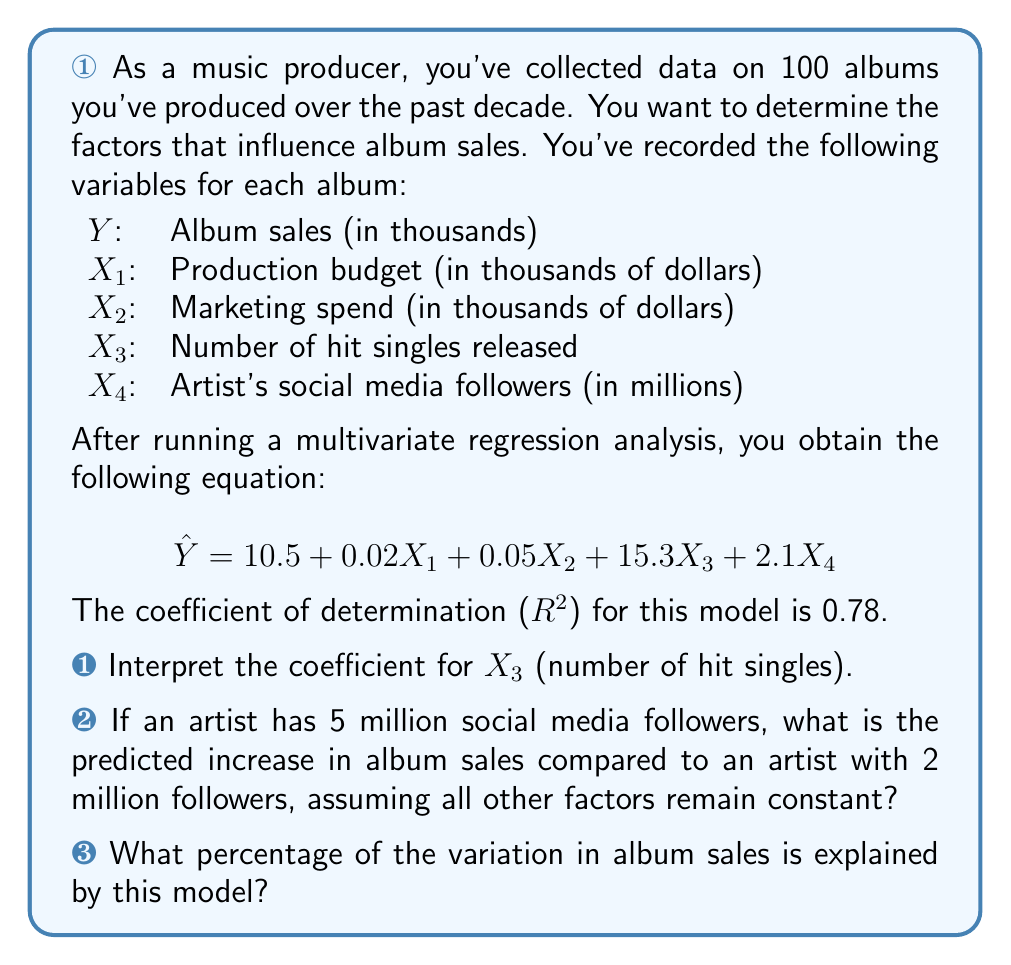Help me with this question. Let's break down this question and answer each part:

a) The coefficient for $X_3$ (number of hit singles) is 15.3. This means that for each additional hit single released, the model predicts an increase of 15,300 album sales, assuming all other variables remain constant. This interpretation is based on the fact that our dependent variable (Y) is in thousands of sales, so we need to multiply the coefficient by 1000 to get the actual number of sales.

b) To calculate the predicted increase in album sales due to the difference in social media followers:

1. Calculate the difference in followers: 5 million - 2 million = 3 million
2. Multiply this difference by the coefficient for $X_4$: 
   $3 * 2.1 = 6.3$

The predicted increase is 6.3 thousand album sales, or 6,300 sales.

c) The coefficient of determination ($R^2$) is given as 0.78. This value represents the proportion of variance in the dependent variable (album sales) that is predictable from the independent variables (production factors). To express this as a percentage, we multiply by 100:

$0.78 * 100 = 78\%$

Therefore, 78% of the variation in album sales is explained by this model.
Answer: a) For each additional hit single released, the model predicts an increase of 15,300 album sales, assuming all other variables remain constant.

b) The predicted increase in album sales for an artist with 5 million followers compared to an artist with 2 million followers is 6,300 sales, assuming all other factors remain constant.

c) 78% of the variation in album sales is explained by this model. 